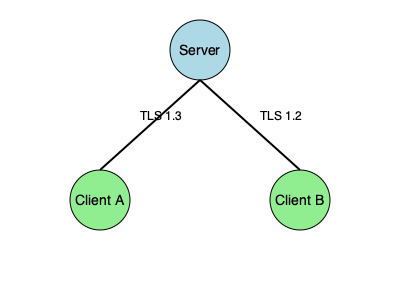In the network topology shown, which client connection is more secure for transmitting sensitive customer session data, and why? To determine which client connection is more secure for transmitting sensitive customer session data, we need to compare the security features of TLS 1.2 and TLS 1.3:

1. TLS 1.3 (Client A):
   a) Improved handshake process, reducing latency and attack surface
   b) Removal of outdated and insecure cryptographic algorithms
   c) Perfect Forward Secrecy (PFS) by default
   d) Encrypted handshake messages for better privacy

2. TLS 1.2 (Client B):
   a) Still widely used and considered secure when properly configured
   b) Supports a wider range of cipher suites, including some less secure options
   c) PFS is optional and not enabled by default
   d) Handshake messages are not encrypted

3. Key differences:
   a) TLS 1.3 offers better performance due to reduced handshake complexity
   b) TLS 1.3 provides stronger security guarantees by removing vulnerable features
   c) TLS 1.3 ensures PFS for all connections, improving long-term data protection

4. Conclusion:
   The connection between the Server and Client A using TLS 1.3 is more secure for transmitting sensitive customer session data due to its enhanced security features, improved performance, and mandatory implementation of modern cryptographic practices.
Answer: Client A (TLS 1.3) 